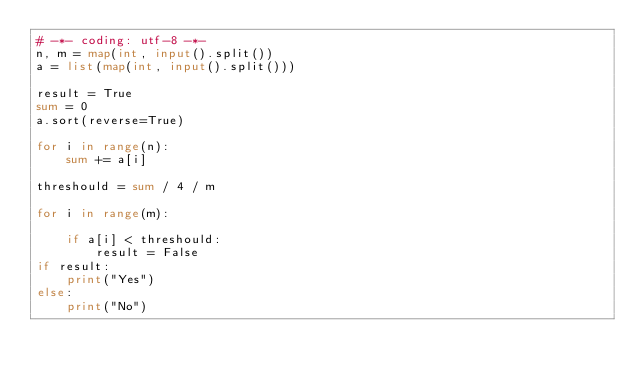<code> <loc_0><loc_0><loc_500><loc_500><_Python_># -*- coding: utf-8 -*-
n, m = map(int, input().split())
a = list(map(int, input().split()))

result = True
sum = 0
a.sort(reverse=True)

for i in range(n):
    sum += a[i]

threshould = sum / 4 / m

for i in range(m):

    if a[i] < threshould:
        result = False
if result:
    print("Yes")
else:
    print("No")
</code> 